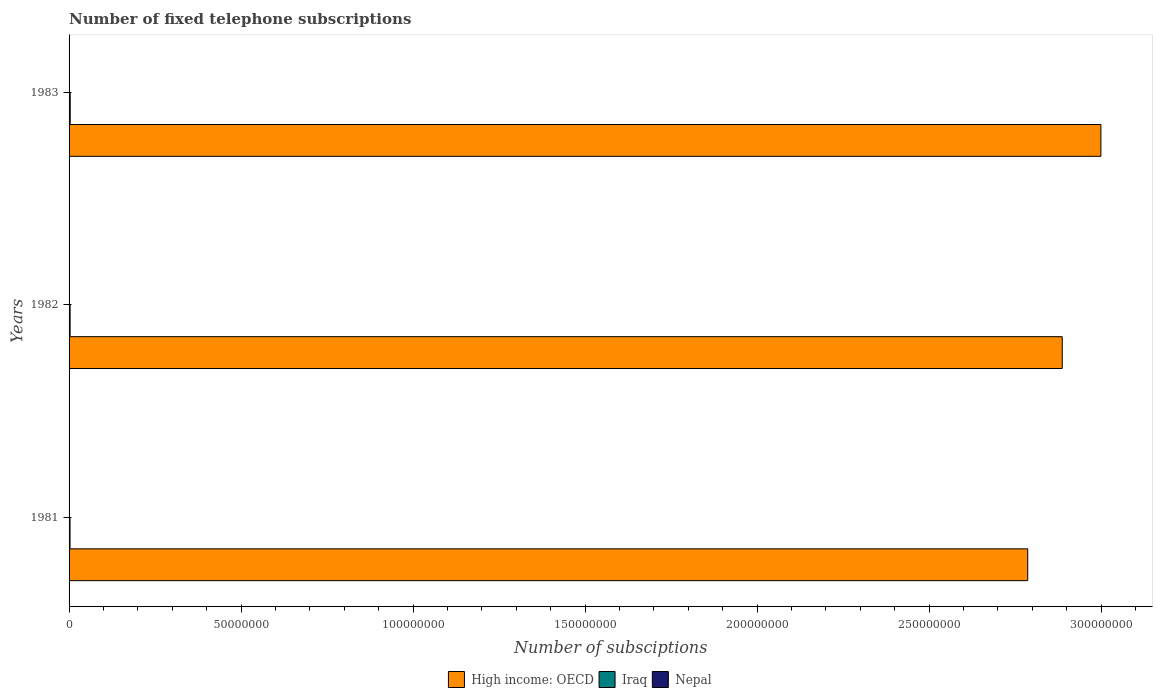Are the number of bars on each tick of the Y-axis equal?
Keep it short and to the point. Yes. How many bars are there on the 2nd tick from the top?
Make the answer very short. 3. How many bars are there on the 2nd tick from the bottom?
Ensure brevity in your answer.  3. What is the number of fixed telephone subscriptions in Nepal in 1981?
Offer a very short reply. 1.28e+04. Across all years, what is the maximum number of fixed telephone subscriptions in Iraq?
Your answer should be compact. 3.25e+05. Across all years, what is the minimum number of fixed telephone subscriptions in High income: OECD?
Provide a short and direct response. 2.79e+08. In which year was the number of fixed telephone subscriptions in High income: OECD minimum?
Ensure brevity in your answer.  1981. What is the total number of fixed telephone subscriptions in High income: OECD in the graph?
Provide a short and direct response. 8.67e+08. What is the difference between the number of fixed telephone subscriptions in Nepal in 1982 and that in 1983?
Your answer should be very brief. -2206. What is the difference between the number of fixed telephone subscriptions in High income: OECD in 1983 and the number of fixed telephone subscriptions in Iraq in 1982?
Make the answer very short. 3.00e+08. What is the average number of fixed telephone subscriptions in High income: OECD per year?
Give a very brief answer. 2.89e+08. In the year 1981, what is the difference between the number of fixed telephone subscriptions in Iraq and number of fixed telephone subscriptions in Nepal?
Ensure brevity in your answer.  2.62e+05. In how many years, is the number of fixed telephone subscriptions in High income: OECD greater than 10000000 ?
Your answer should be very brief. 3. What is the ratio of the number of fixed telephone subscriptions in Iraq in 1981 to that in 1982?
Keep it short and to the point. 0.92. Is the number of fixed telephone subscriptions in Iraq in 1981 less than that in 1983?
Provide a succinct answer. Yes. Is the difference between the number of fixed telephone subscriptions in Iraq in 1982 and 1983 greater than the difference between the number of fixed telephone subscriptions in Nepal in 1982 and 1983?
Offer a terse response. No. What is the difference between the highest and the second highest number of fixed telephone subscriptions in Nepal?
Give a very brief answer. 2206. What is the difference between the highest and the lowest number of fixed telephone subscriptions in High income: OECD?
Give a very brief answer. 2.13e+07. In how many years, is the number of fixed telephone subscriptions in High income: OECD greater than the average number of fixed telephone subscriptions in High income: OECD taken over all years?
Your answer should be compact. 1. Is the sum of the number of fixed telephone subscriptions in Nepal in 1981 and 1982 greater than the maximum number of fixed telephone subscriptions in High income: OECD across all years?
Your answer should be compact. No. What does the 2nd bar from the top in 1982 represents?
Ensure brevity in your answer.  Iraq. What does the 3rd bar from the bottom in 1981 represents?
Your answer should be compact. Nepal. Is it the case that in every year, the sum of the number of fixed telephone subscriptions in High income: OECD and number of fixed telephone subscriptions in Iraq is greater than the number of fixed telephone subscriptions in Nepal?
Your answer should be compact. Yes. Are all the bars in the graph horizontal?
Ensure brevity in your answer.  Yes. How many years are there in the graph?
Offer a very short reply. 3. Are the values on the major ticks of X-axis written in scientific E-notation?
Keep it short and to the point. No. Does the graph contain grids?
Offer a terse response. No. Where does the legend appear in the graph?
Your answer should be compact. Bottom center. How are the legend labels stacked?
Your answer should be very brief. Horizontal. What is the title of the graph?
Offer a terse response. Number of fixed telephone subscriptions. Does "Central African Republic" appear as one of the legend labels in the graph?
Your answer should be very brief. No. What is the label or title of the X-axis?
Provide a succinct answer. Number of subsciptions. What is the Number of subsciptions in High income: OECD in 1981?
Ensure brevity in your answer.  2.79e+08. What is the Number of subsciptions of Iraq in 1981?
Provide a short and direct response. 2.75e+05. What is the Number of subsciptions in Nepal in 1981?
Ensure brevity in your answer.  1.28e+04. What is the Number of subsciptions of High income: OECD in 1982?
Provide a short and direct response. 2.89e+08. What is the Number of subsciptions in Iraq in 1982?
Keep it short and to the point. 3.00e+05. What is the Number of subsciptions of Nepal in 1982?
Offer a terse response. 1.43e+04. What is the Number of subsciptions of High income: OECD in 1983?
Give a very brief answer. 3.00e+08. What is the Number of subsciptions of Iraq in 1983?
Ensure brevity in your answer.  3.25e+05. What is the Number of subsciptions in Nepal in 1983?
Your answer should be compact. 1.65e+04. Across all years, what is the maximum Number of subsciptions of High income: OECD?
Keep it short and to the point. 3.00e+08. Across all years, what is the maximum Number of subsciptions of Iraq?
Offer a terse response. 3.25e+05. Across all years, what is the maximum Number of subsciptions of Nepal?
Your response must be concise. 1.65e+04. Across all years, what is the minimum Number of subsciptions in High income: OECD?
Provide a short and direct response. 2.79e+08. Across all years, what is the minimum Number of subsciptions of Iraq?
Provide a short and direct response. 2.75e+05. Across all years, what is the minimum Number of subsciptions of Nepal?
Your answer should be compact. 1.28e+04. What is the total Number of subsciptions in High income: OECD in the graph?
Provide a succinct answer. 8.67e+08. What is the total Number of subsciptions in Iraq in the graph?
Your answer should be very brief. 9.00e+05. What is the total Number of subsciptions in Nepal in the graph?
Your response must be concise. 4.36e+04. What is the difference between the Number of subsciptions in High income: OECD in 1981 and that in 1982?
Make the answer very short. -1.00e+07. What is the difference between the Number of subsciptions of Iraq in 1981 and that in 1982?
Your response must be concise. -2.50e+04. What is the difference between the Number of subsciptions in Nepal in 1981 and that in 1982?
Your answer should be very brief. -1490. What is the difference between the Number of subsciptions of High income: OECD in 1981 and that in 1983?
Provide a succinct answer. -2.13e+07. What is the difference between the Number of subsciptions of Iraq in 1981 and that in 1983?
Your answer should be compact. -5.04e+04. What is the difference between the Number of subsciptions of Nepal in 1981 and that in 1983?
Provide a succinct answer. -3696. What is the difference between the Number of subsciptions of High income: OECD in 1982 and that in 1983?
Keep it short and to the point. -1.12e+07. What is the difference between the Number of subsciptions in Iraq in 1982 and that in 1983?
Provide a short and direct response. -2.54e+04. What is the difference between the Number of subsciptions in Nepal in 1982 and that in 1983?
Offer a terse response. -2206. What is the difference between the Number of subsciptions in High income: OECD in 1981 and the Number of subsciptions in Iraq in 1982?
Provide a succinct answer. 2.78e+08. What is the difference between the Number of subsciptions of High income: OECD in 1981 and the Number of subsciptions of Nepal in 1982?
Your answer should be very brief. 2.79e+08. What is the difference between the Number of subsciptions in Iraq in 1981 and the Number of subsciptions in Nepal in 1982?
Your answer should be very brief. 2.61e+05. What is the difference between the Number of subsciptions of High income: OECD in 1981 and the Number of subsciptions of Iraq in 1983?
Your response must be concise. 2.78e+08. What is the difference between the Number of subsciptions of High income: OECD in 1981 and the Number of subsciptions of Nepal in 1983?
Make the answer very short. 2.79e+08. What is the difference between the Number of subsciptions of Iraq in 1981 and the Number of subsciptions of Nepal in 1983?
Make the answer very short. 2.59e+05. What is the difference between the Number of subsciptions in High income: OECD in 1982 and the Number of subsciptions in Iraq in 1983?
Offer a terse response. 2.88e+08. What is the difference between the Number of subsciptions in High income: OECD in 1982 and the Number of subsciptions in Nepal in 1983?
Your answer should be compact. 2.89e+08. What is the difference between the Number of subsciptions in Iraq in 1982 and the Number of subsciptions in Nepal in 1983?
Your response must be concise. 2.84e+05. What is the average Number of subsciptions in High income: OECD per year?
Give a very brief answer. 2.89e+08. What is the average Number of subsciptions in Iraq per year?
Provide a short and direct response. 3.00e+05. What is the average Number of subsciptions in Nepal per year?
Offer a very short reply. 1.45e+04. In the year 1981, what is the difference between the Number of subsciptions of High income: OECD and Number of subsciptions of Iraq?
Your answer should be compact. 2.78e+08. In the year 1981, what is the difference between the Number of subsciptions of High income: OECD and Number of subsciptions of Nepal?
Give a very brief answer. 2.79e+08. In the year 1981, what is the difference between the Number of subsciptions in Iraq and Number of subsciptions in Nepal?
Offer a terse response. 2.62e+05. In the year 1982, what is the difference between the Number of subsciptions in High income: OECD and Number of subsciptions in Iraq?
Give a very brief answer. 2.88e+08. In the year 1982, what is the difference between the Number of subsciptions of High income: OECD and Number of subsciptions of Nepal?
Ensure brevity in your answer.  2.89e+08. In the year 1982, what is the difference between the Number of subsciptions of Iraq and Number of subsciptions of Nepal?
Give a very brief answer. 2.86e+05. In the year 1983, what is the difference between the Number of subsciptions of High income: OECD and Number of subsciptions of Iraq?
Offer a very short reply. 3.00e+08. In the year 1983, what is the difference between the Number of subsciptions in High income: OECD and Number of subsciptions in Nepal?
Your answer should be very brief. 3.00e+08. In the year 1983, what is the difference between the Number of subsciptions of Iraq and Number of subsciptions of Nepal?
Your response must be concise. 3.09e+05. What is the ratio of the Number of subsciptions of High income: OECD in 1981 to that in 1982?
Offer a terse response. 0.97. What is the ratio of the Number of subsciptions of Iraq in 1981 to that in 1982?
Give a very brief answer. 0.92. What is the ratio of the Number of subsciptions of Nepal in 1981 to that in 1982?
Your answer should be compact. 0.9. What is the ratio of the Number of subsciptions in High income: OECD in 1981 to that in 1983?
Ensure brevity in your answer.  0.93. What is the ratio of the Number of subsciptions of Iraq in 1981 to that in 1983?
Your answer should be compact. 0.84. What is the ratio of the Number of subsciptions in Nepal in 1981 to that in 1983?
Provide a short and direct response. 0.78. What is the ratio of the Number of subsciptions of High income: OECD in 1982 to that in 1983?
Offer a terse response. 0.96. What is the ratio of the Number of subsciptions in Iraq in 1982 to that in 1983?
Offer a very short reply. 0.92. What is the ratio of the Number of subsciptions in Nepal in 1982 to that in 1983?
Your response must be concise. 0.87. What is the difference between the highest and the second highest Number of subsciptions in High income: OECD?
Keep it short and to the point. 1.12e+07. What is the difference between the highest and the second highest Number of subsciptions in Iraq?
Give a very brief answer. 2.54e+04. What is the difference between the highest and the second highest Number of subsciptions of Nepal?
Keep it short and to the point. 2206. What is the difference between the highest and the lowest Number of subsciptions in High income: OECD?
Your answer should be very brief. 2.13e+07. What is the difference between the highest and the lowest Number of subsciptions of Iraq?
Your answer should be compact. 5.04e+04. What is the difference between the highest and the lowest Number of subsciptions in Nepal?
Provide a short and direct response. 3696. 